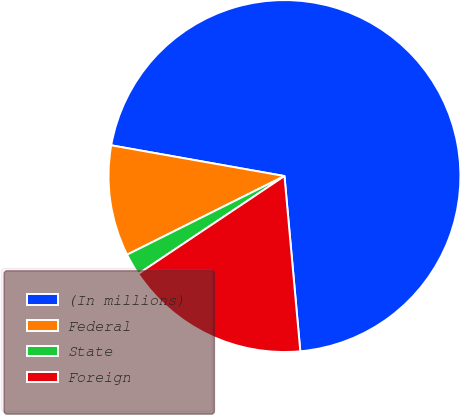<chart> <loc_0><loc_0><loc_500><loc_500><pie_chart><fcel>(In millions)<fcel>Federal<fcel>State<fcel>Foreign<nl><fcel>70.77%<fcel>10.17%<fcel>2.01%<fcel>17.05%<nl></chart> 